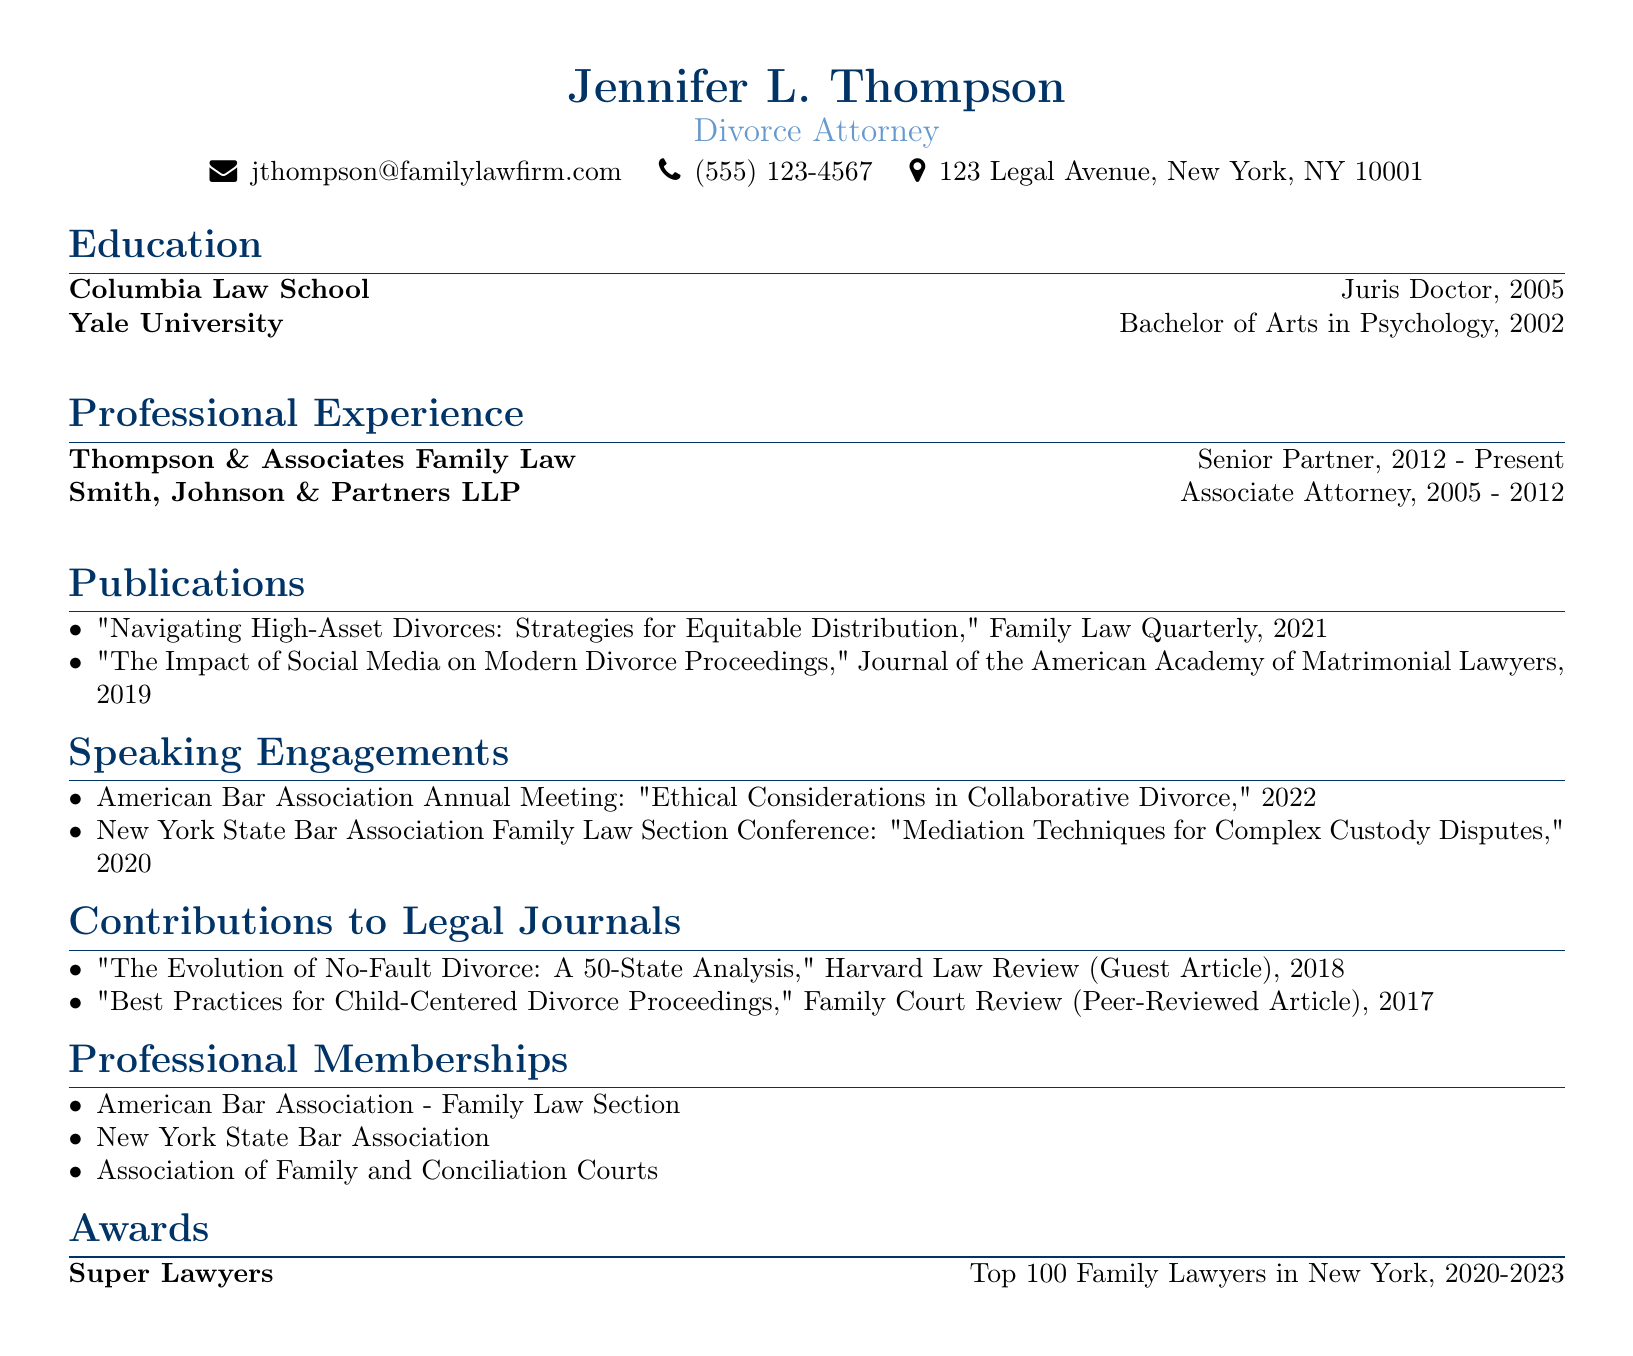what is the name of the attorney? The name of the attorney is mentioned at the beginning of the document.
Answer: Jennifer L. Thompson what is the highest degree obtained by Jennifer L. Thompson? The highest degree is listed in the education section of the document.
Answer: Juris Doctor what year did Jennifer L. Thompson graduate from Columbia Law School? The graduation year is provided alongside the degree information in the education section.
Answer: 2005 how long has Jennifer L. Thompson been a Senior Partner at Thompson & Associates Family Law? The duration is specified under the professional experience section, indicating her tenure as Senior Partner.
Answer: 2012 - Present which journal published the article "Navigating High-Asset Divorces: Strategies for Equitable Distribution"? This information is detailed under the publications section.
Answer: Family Law Quarterly in what year did Jennifer L. Thompson present at the American Bar Association Annual Meeting? The year of the speaking engagement is noted in the speaking engagements section.
Answer: 2022 what type of article is "Best Practices for Child-Centered Divorce Proceedings"? The type of contribution is indicated in the contributions to legal journals section.
Answer: Peer-Reviewed Article which award has Jennifer L. Thompson received for her work in Family Law? The specific award is noted in the awards section of the document.
Answer: Top 100 Family Lawyers in New York how many professional memberships does Jennifer L. Thompson have listed? The count can be deduced from the entries in the professional memberships section.
Answer: 3 what is the focus of Jennifer L. Thompson’s guest article in Harvard Law Review? The topic is mentioned in the contributions section and indicates the content covered in her guest article.
Answer: The Evolution of No-Fault Divorce: A 50-State Analysis 